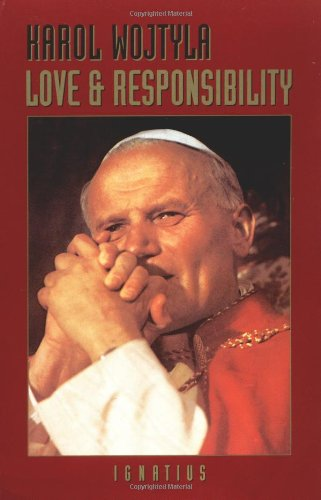What philosophical themes are explored in 'Love and Responsibility' by Karol Wojtyla? The book delves into various philosophical themes including the nature of relationships, love, and morality, examining these concepts through a comprehensive ethical and Christian framework. 